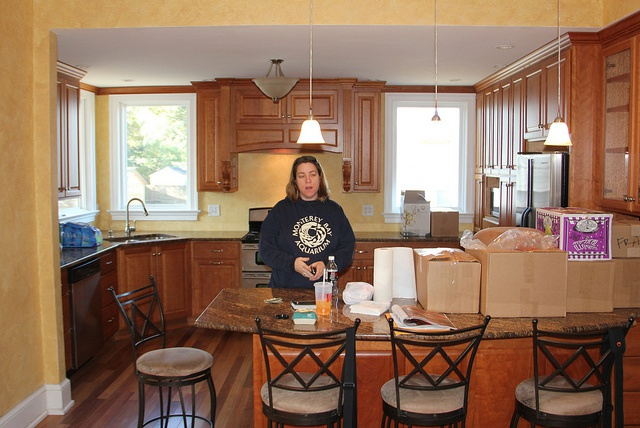Describe the objects in this image and their specific colors. I can see dining table in tan, maroon, brown, and black tones, people in tan, black, gray, and maroon tones, chair in tan, black, gray, and maroon tones, chair in tan, black, maroon, and gray tones, and chair in tan, black, brown, and gray tones in this image. 